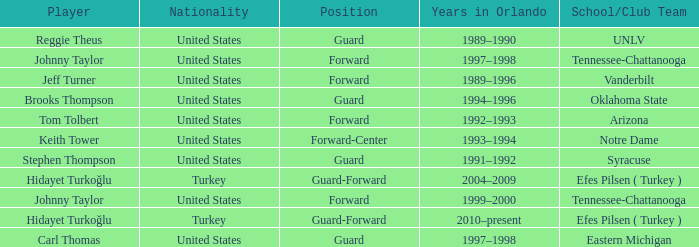What is the Position of the player from Vanderbilt? Forward. 